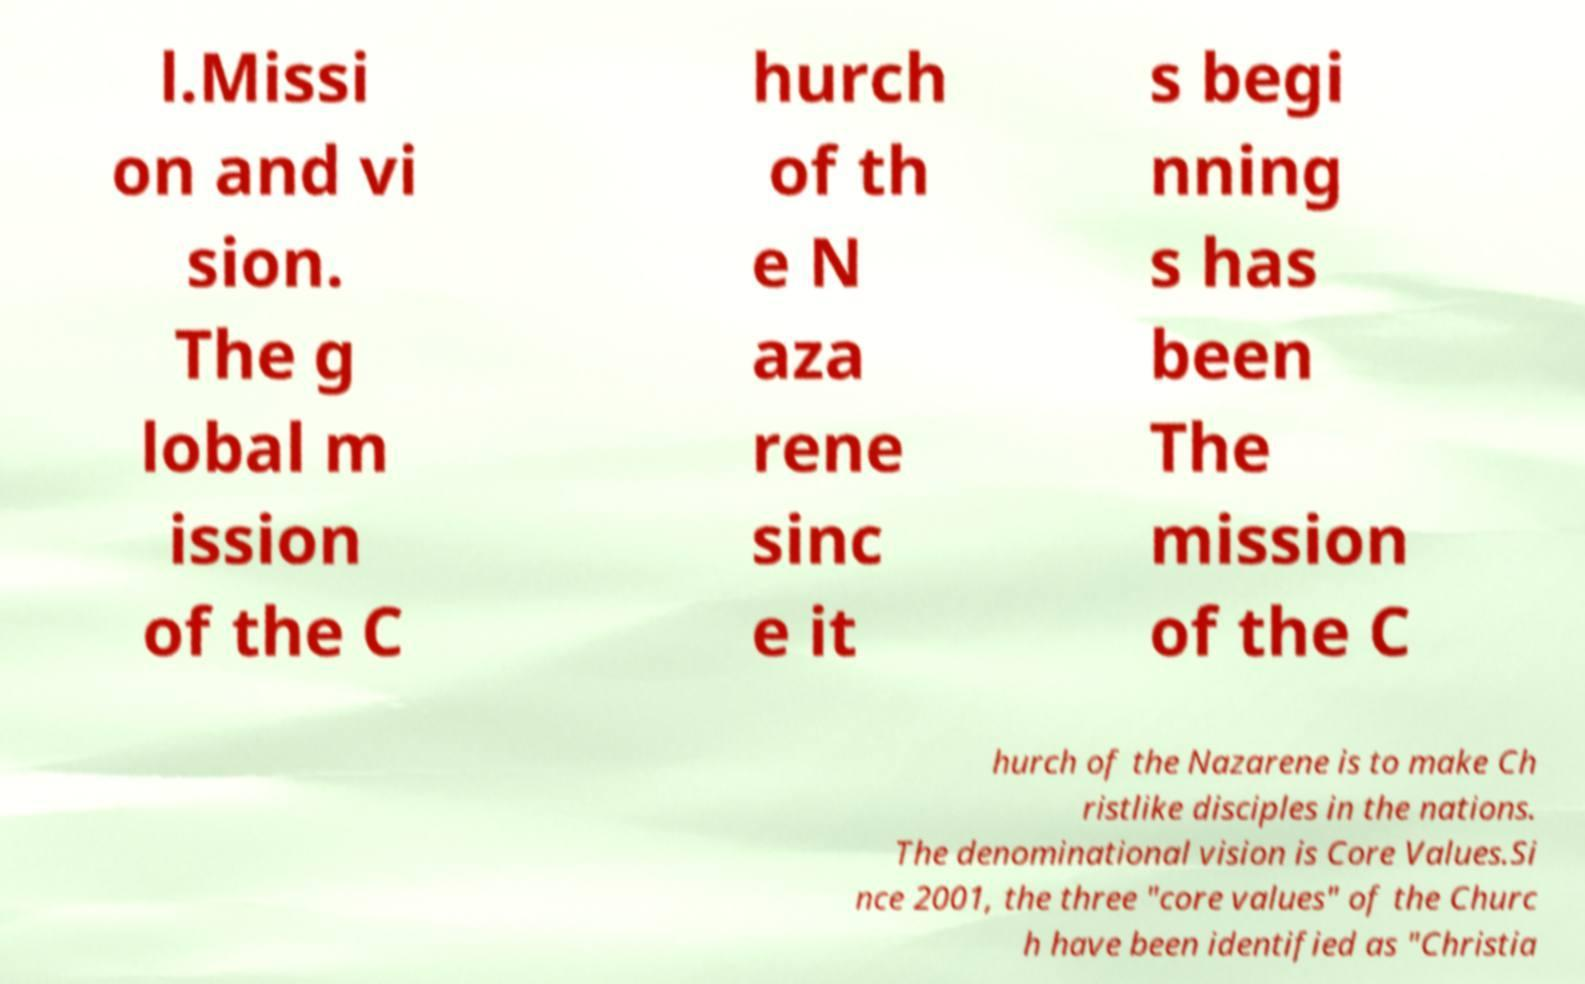Please identify and transcribe the text found in this image. l.Missi on and vi sion. The g lobal m ission of the C hurch of th e N aza rene sinc e it s begi nning s has been The mission of the C hurch of the Nazarene is to make Ch ristlike disciples in the nations. The denominational vision is Core Values.Si nce 2001, the three "core values" of the Churc h have been identified as "Christia 